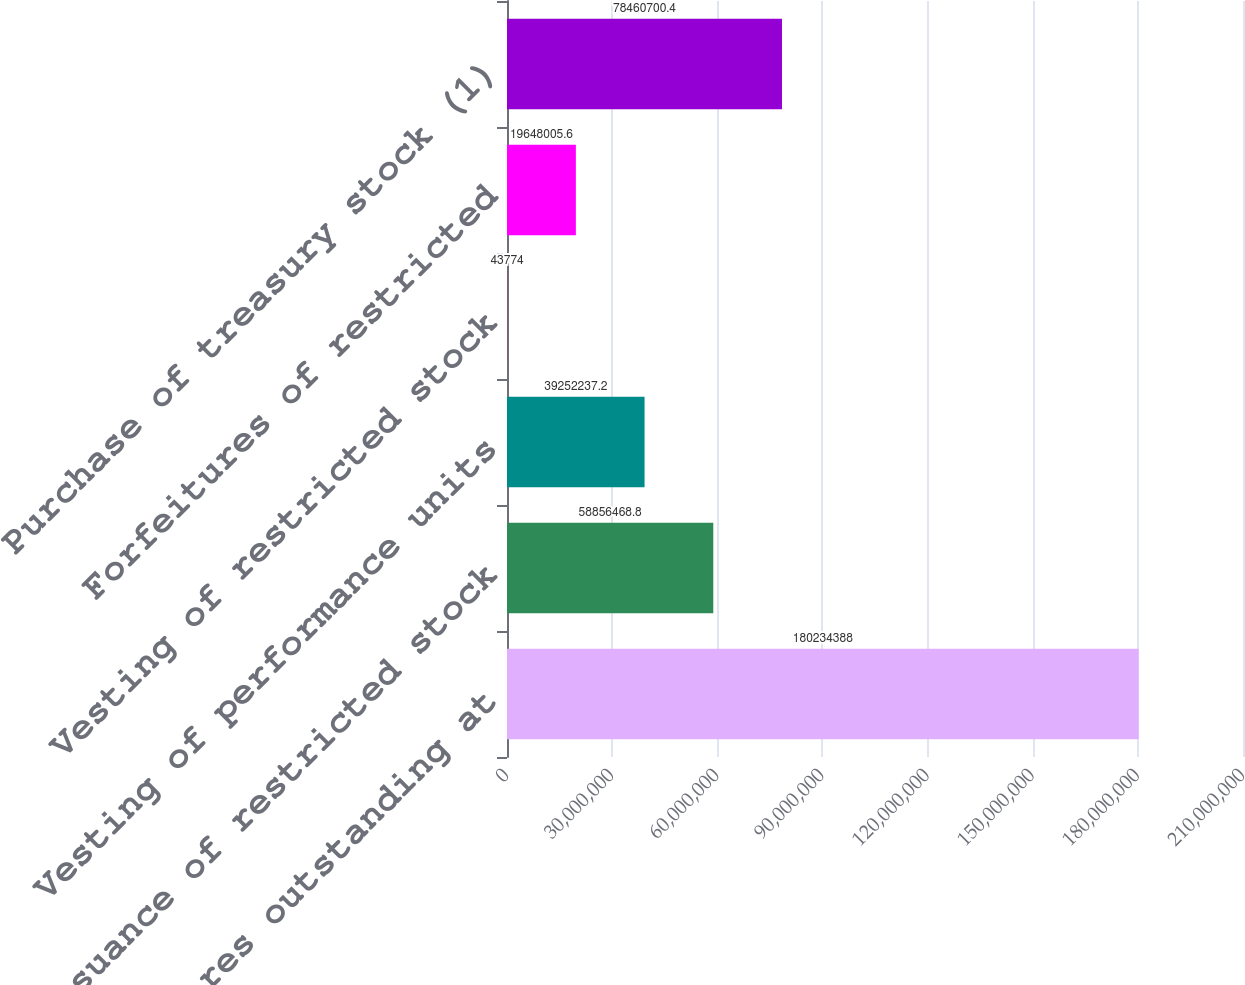Convert chart. <chart><loc_0><loc_0><loc_500><loc_500><bar_chart><fcel>Common shares outstanding at<fcel>Issuance of restricted stock<fcel>Vesting of performance units<fcel>Vesting of restricted stock<fcel>Forfeitures of restricted<fcel>Purchase of treasury stock (1)<nl><fcel>1.80234e+08<fcel>5.88565e+07<fcel>3.92522e+07<fcel>43774<fcel>1.9648e+07<fcel>7.84607e+07<nl></chart> 